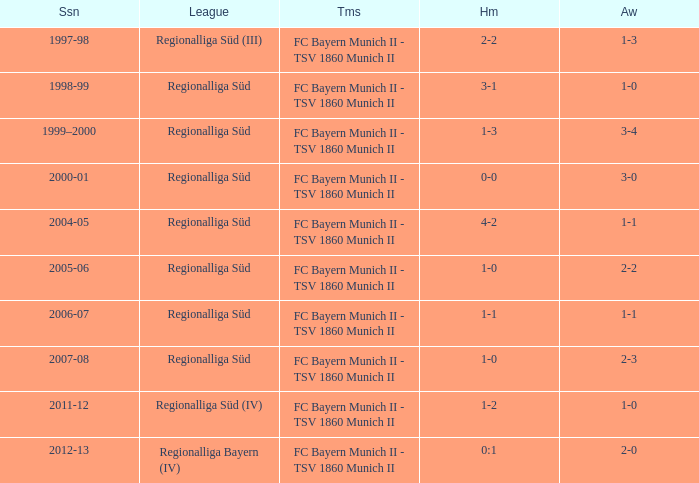What is the home with a 1-1 away in the 2004-05 season? 4-2. 